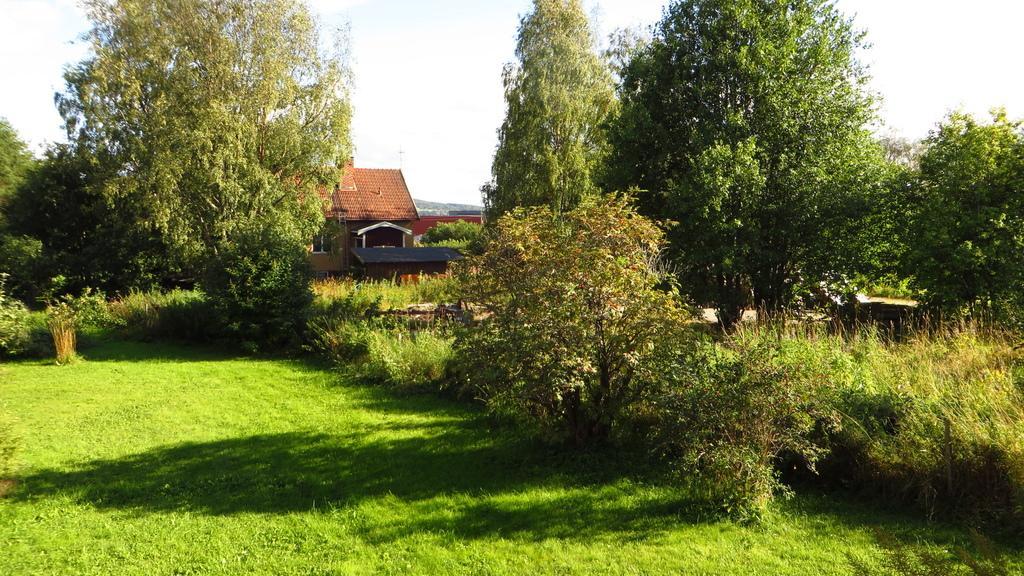Please provide a concise description of this image. In the picture there is a house and around the house there are plenty of trees and grass. 